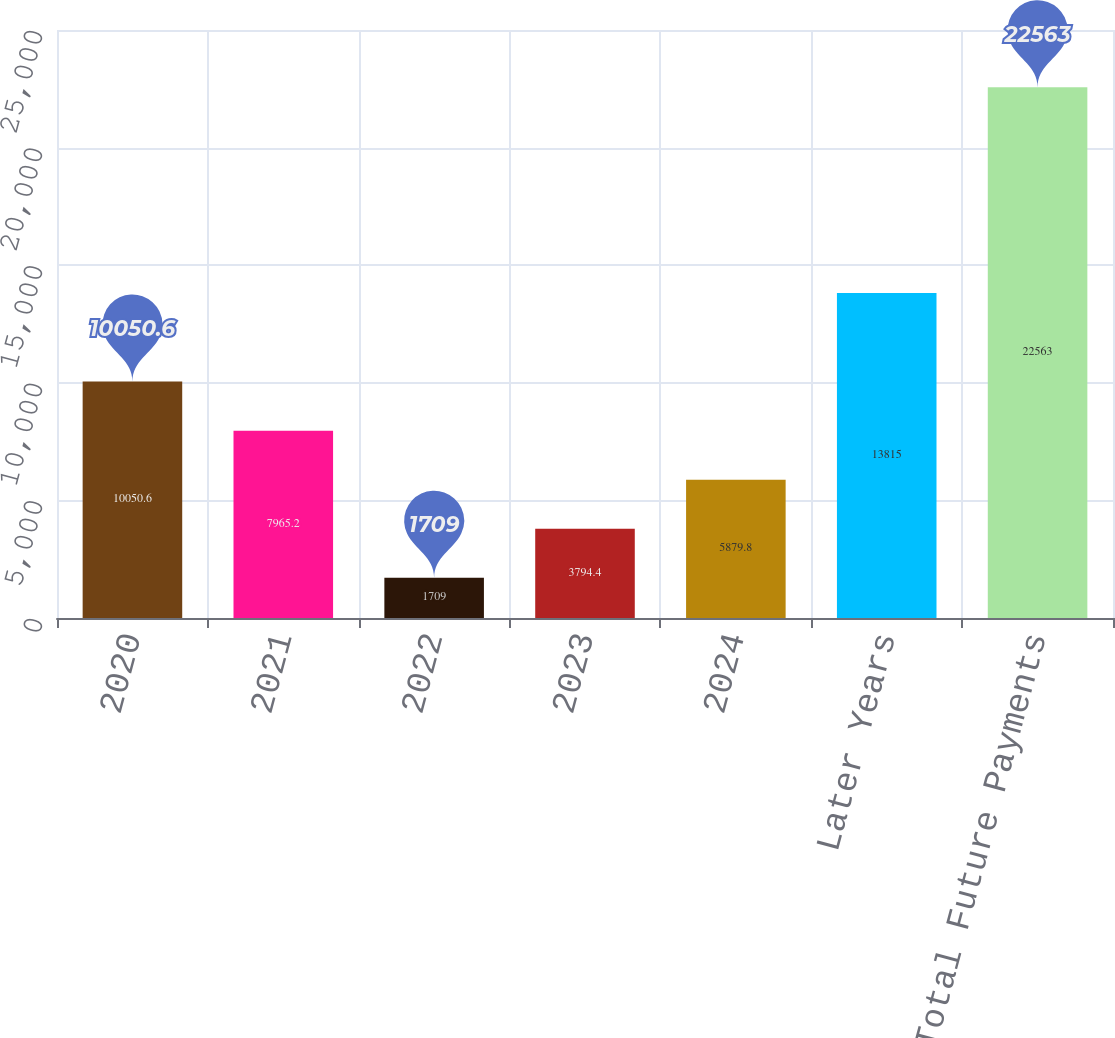Convert chart. <chart><loc_0><loc_0><loc_500><loc_500><bar_chart><fcel>2020<fcel>2021<fcel>2022<fcel>2023<fcel>2024<fcel>Later Years<fcel>Total Future Payments<nl><fcel>10050.6<fcel>7965.2<fcel>1709<fcel>3794.4<fcel>5879.8<fcel>13815<fcel>22563<nl></chart> 